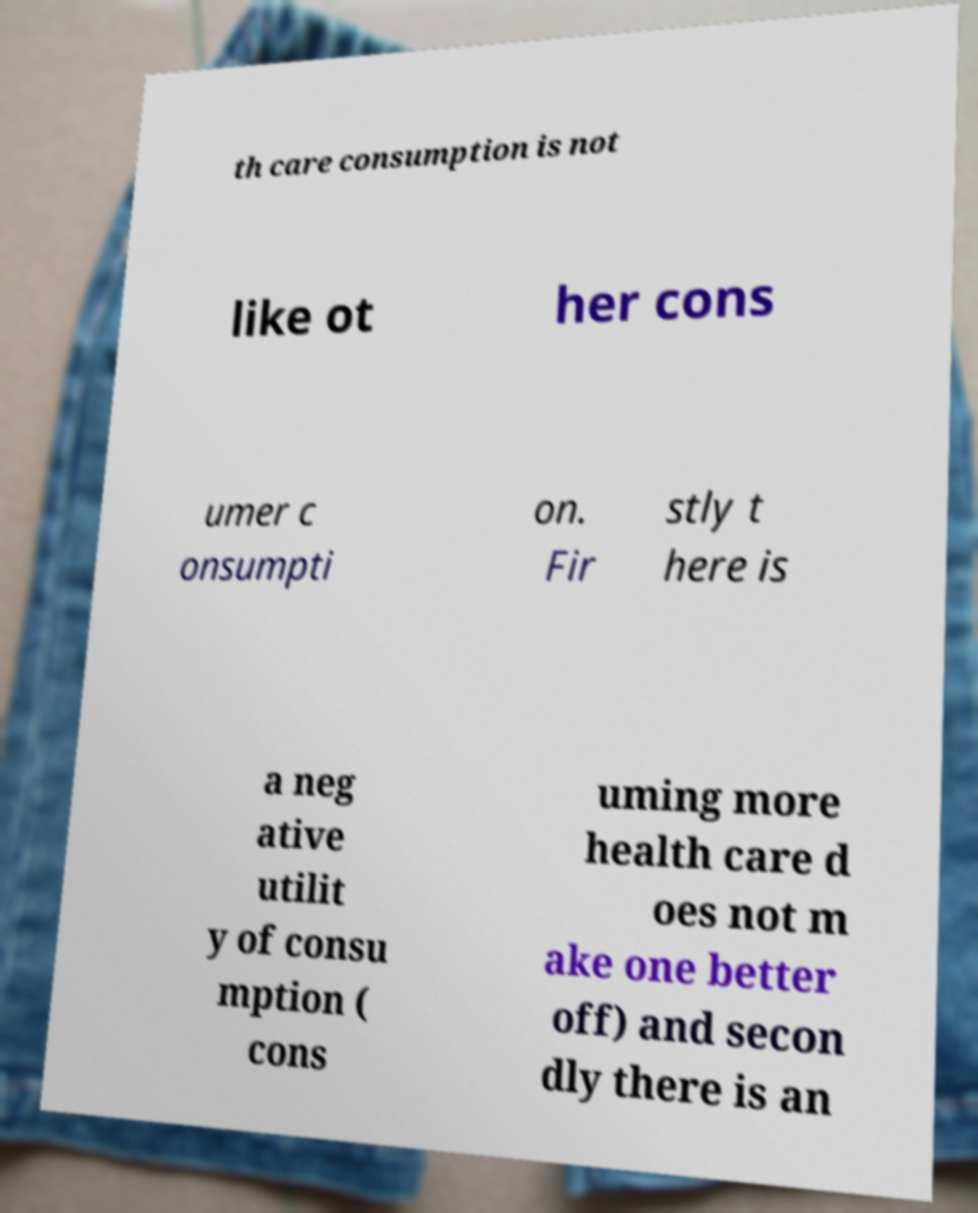There's text embedded in this image that I need extracted. Can you transcribe it verbatim? th care consumption is not like ot her cons umer c onsumpti on. Fir stly t here is a neg ative utilit y of consu mption ( cons uming more health care d oes not m ake one better off) and secon dly there is an 